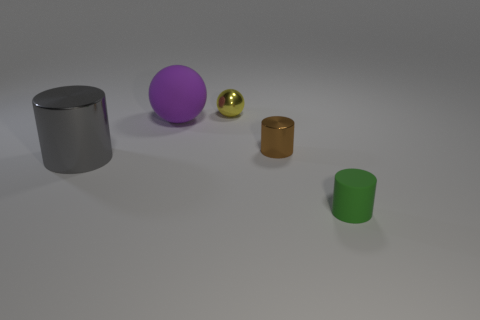Add 1 red rubber cylinders. How many objects exist? 6 Subtract all balls. How many objects are left? 3 Subtract all green metallic balls. Subtract all big gray things. How many objects are left? 4 Add 2 small metallic balls. How many small metallic balls are left? 3 Add 5 small yellow blocks. How many small yellow blocks exist? 5 Subtract 1 gray cylinders. How many objects are left? 4 